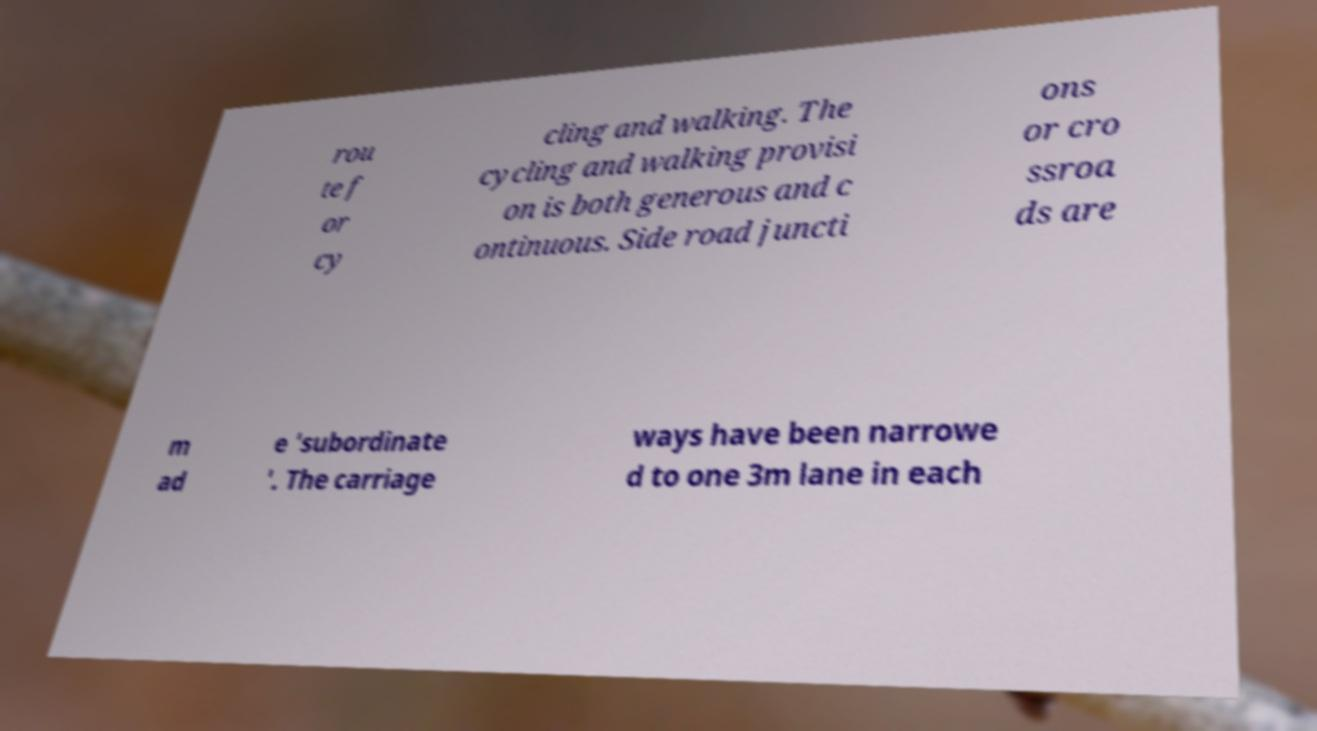Please read and relay the text visible in this image. What does it say? rou te f or cy cling and walking. The cycling and walking provisi on is both generous and c ontinuous. Side road juncti ons or cro ssroa ds are m ad e 'subordinate '. The carriage ways have been narrowe d to one 3m lane in each 